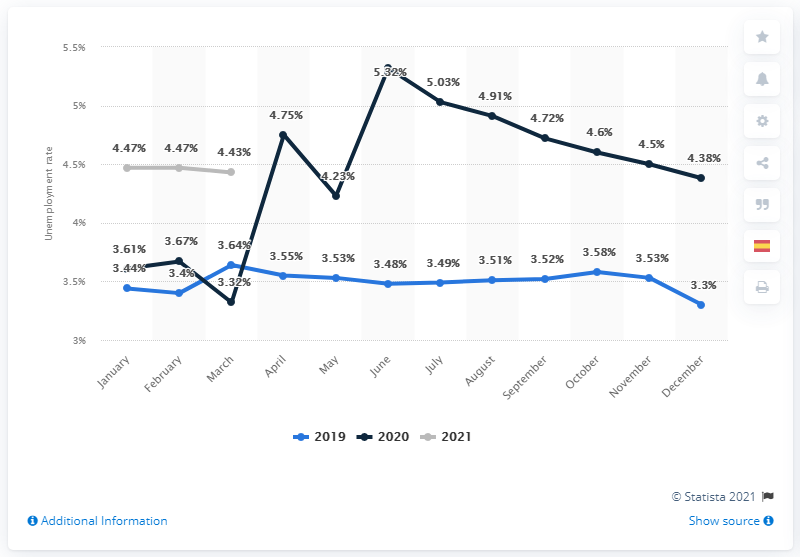Give some essential details in this illustration. According to March 2021 data, approximately 4.43% of Mexico's population was considered unemployed. 